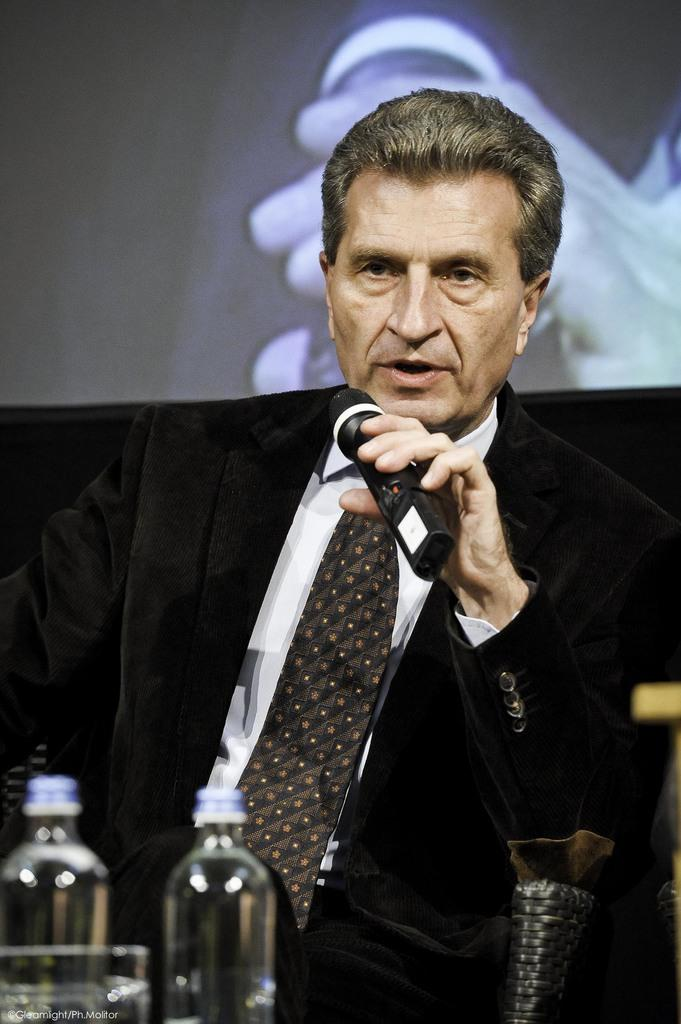What is the man in the image wearing? The man is wearing a black suit in the image. What is the man doing while wearing the suit? The man is sitting on a chair and holding a mic. What items are in front of the man? There are bottles and a glass in front of the man. What can be seen on the wall in the image? There is a screen on the wall in the image. What type of eggs can be seen on the screen in the image? There are no eggs present in the image, and the screen on the wall does not display any eggs. 